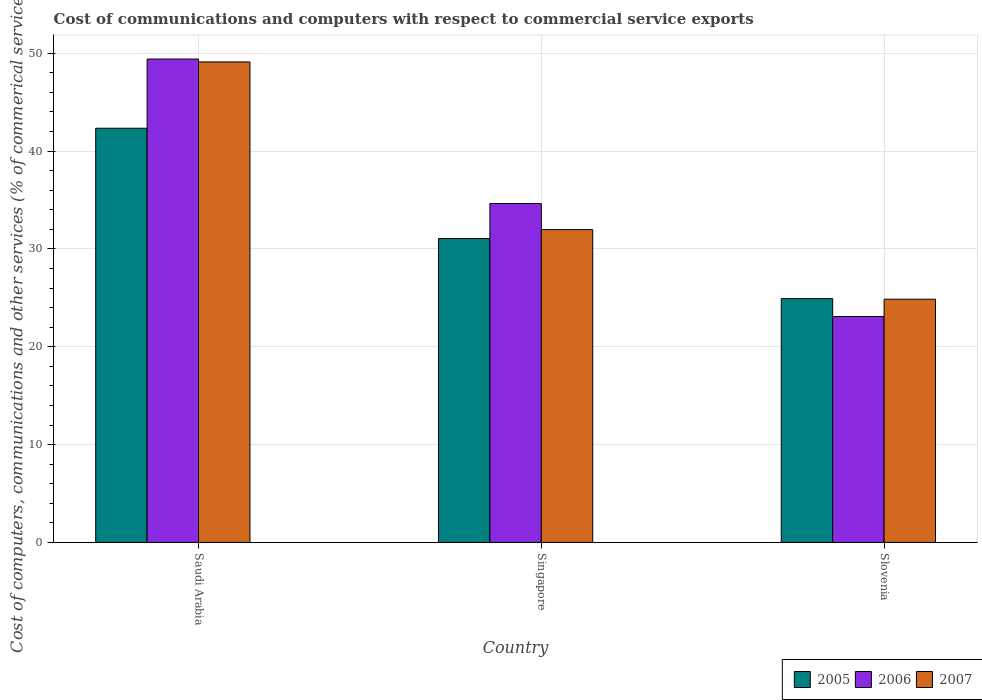Are the number of bars per tick equal to the number of legend labels?
Your answer should be very brief. Yes. Are the number of bars on each tick of the X-axis equal?
Your response must be concise. Yes. How many bars are there on the 3rd tick from the left?
Your answer should be very brief. 3. How many bars are there on the 1st tick from the right?
Your answer should be compact. 3. What is the label of the 1st group of bars from the left?
Ensure brevity in your answer.  Saudi Arabia. What is the cost of communications and computers in 2005 in Slovenia?
Your response must be concise. 24.93. Across all countries, what is the maximum cost of communications and computers in 2007?
Your answer should be very brief. 49.11. Across all countries, what is the minimum cost of communications and computers in 2005?
Keep it short and to the point. 24.93. In which country was the cost of communications and computers in 2007 maximum?
Your answer should be very brief. Saudi Arabia. In which country was the cost of communications and computers in 2007 minimum?
Offer a terse response. Slovenia. What is the total cost of communications and computers in 2006 in the graph?
Offer a terse response. 107.15. What is the difference between the cost of communications and computers in 2007 in Saudi Arabia and that in Slovenia?
Your response must be concise. 24.25. What is the difference between the cost of communications and computers in 2007 in Saudi Arabia and the cost of communications and computers in 2005 in Singapore?
Provide a short and direct response. 18.05. What is the average cost of communications and computers in 2007 per country?
Offer a terse response. 35.32. What is the difference between the cost of communications and computers of/in 2007 and cost of communications and computers of/in 2005 in Saudi Arabia?
Provide a short and direct response. 6.77. What is the ratio of the cost of communications and computers in 2007 in Saudi Arabia to that in Slovenia?
Ensure brevity in your answer.  1.98. Is the cost of communications and computers in 2005 in Singapore less than that in Slovenia?
Offer a very short reply. No. What is the difference between the highest and the second highest cost of communications and computers in 2005?
Your answer should be very brief. -17.41. What is the difference between the highest and the lowest cost of communications and computers in 2007?
Provide a short and direct response. 24.25. Is the sum of the cost of communications and computers in 2006 in Saudi Arabia and Slovenia greater than the maximum cost of communications and computers in 2005 across all countries?
Your response must be concise. Yes. How many countries are there in the graph?
Make the answer very short. 3. Does the graph contain any zero values?
Ensure brevity in your answer.  No. Where does the legend appear in the graph?
Your response must be concise. Bottom right. How many legend labels are there?
Give a very brief answer. 3. What is the title of the graph?
Your response must be concise. Cost of communications and computers with respect to commercial service exports. Does "2008" appear as one of the legend labels in the graph?
Provide a succinct answer. No. What is the label or title of the X-axis?
Offer a terse response. Country. What is the label or title of the Y-axis?
Give a very brief answer. Cost of computers, communications and other services (% of commerical service exports). What is the Cost of computers, communications and other services (% of commerical service exports) of 2005 in Saudi Arabia?
Your answer should be compact. 42.34. What is the Cost of computers, communications and other services (% of commerical service exports) in 2006 in Saudi Arabia?
Ensure brevity in your answer.  49.41. What is the Cost of computers, communications and other services (% of commerical service exports) in 2007 in Saudi Arabia?
Make the answer very short. 49.11. What is the Cost of computers, communications and other services (% of commerical service exports) of 2005 in Singapore?
Offer a very short reply. 31.07. What is the Cost of computers, communications and other services (% of commerical service exports) of 2006 in Singapore?
Your response must be concise. 34.64. What is the Cost of computers, communications and other services (% of commerical service exports) in 2007 in Singapore?
Your response must be concise. 31.98. What is the Cost of computers, communications and other services (% of commerical service exports) in 2005 in Slovenia?
Offer a very short reply. 24.93. What is the Cost of computers, communications and other services (% of commerical service exports) of 2006 in Slovenia?
Offer a very short reply. 23.09. What is the Cost of computers, communications and other services (% of commerical service exports) in 2007 in Slovenia?
Your answer should be very brief. 24.86. Across all countries, what is the maximum Cost of computers, communications and other services (% of commerical service exports) of 2005?
Give a very brief answer. 42.34. Across all countries, what is the maximum Cost of computers, communications and other services (% of commerical service exports) of 2006?
Give a very brief answer. 49.41. Across all countries, what is the maximum Cost of computers, communications and other services (% of commerical service exports) of 2007?
Your response must be concise. 49.11. Across all countries, what is the minimum Cost of computers, communications and other services (% of commerical service exports) in 2005?
Offer a very short reply. 24.93. Across all countries, what is the minimum Cost of computers, communications and other services (% of commerical service exports) of 2006?
Keep it short and to the point. 23.09. Across all countries, what is the minimum Cost of computers, communications and other services (% of commerical service exports) of 2007?
Your response must be concise. 24.86. What is the total Cost of computers, communications and other services (% of commerical service exports) of 2005 in the graph?
Make the answer very short. 98.33. What is the total Cost of computers, communications and other services (% of commerical service exports) in 2006 in the graph?
Keep it short and to the point. 107.15. What is the total Cost of computers, communications and other services (% of commerical service exports) of 2007 in the graph?
Give a very brief answer. 105.95. What is the difference between the Cost of computers, communications and other services (% of commerical service exports) of 2005 in Saudi Arabia and that in Singapore?
Your answer should be compact. 11.27. What is the difference between the Cost of computers, communications and other services (% of commerical service exports) in 2006 in Saudi Arabia and that in Singapore?
Keep it short and to the point. 14.77. What is the difference between the Cost of computers, communications and other services (% of commerical service exports) in 2007 in Saudi Arabia and that in Singapore?
Your response must be concise. 17.14. What is the difference between the Cost of computers, communications and other services (% of commerical service exports) of 2005 in Saudi Arabia and that in Slovenia?
Offer a terse response. 17.41. What is the difference between the Cost of computers, communications and other services (% of commerical service exports) in 2006 in Saudi Arabia and that in Slovenia?
Your answer should be very brief. 26.32. What is the difference between the Cost of computers, communications and other services (% of commerical service exports) of 2007 in Saudi Arabia and that in Slovenia?
Provide a succinct answer. 24.25. What is the difference between the Cost of computers, communications and other services (% of commerical service exports) of 2005 in Singapore and that in Slovenia?
Provide a short and direct response. 6.14. What is the difference between the Cost of computers, communications and other services (% of commerical service exports) in 2006 in Singapore and that in Slovenia?
Offer a very short reply. 11.55. What is the difference between the Cost of computers, communications and other services (% of commerical service exports) of 2007 in Singapore and that in Slovenia?
Give a very brief answer. 7.11. What is the difference between the Cost of computers, communications and other services (% of commerical service exports) in 2005 in Saudi Arabia and the Cost of computers, communications and other services (% of commerical service exports) in 2006 in Singapore?
Offer a terse response. 7.69. What is the difference between the Cost of computers, communications and other services (% of commerical service exports) in 2005 in Saudi Arabia and the Cost of computers, communications and other services (% of commerical service exports) in 2007 in Singapore?
Provide a succinct answer. 10.36. What is the difference between the Cost of computers, communications and other services (% of commerical service exports) of 2006 in Saudi Arabia and the Cost of computers, communications and other services (% of commerical service exports) of 2007 in Singapore?
Ensure brevity in your answer.  17.44. What is the difference between the Cost of computers, communications and other services (% of commerical service exports) of 2005 in Saudi Arabia and the Cost of computers, communications and other services (% of commerical service exports) of 2006 in Slovenia?
Your answer should be compact. 19.25. What is the difference between the Cost of computers, communications and other services (% of commerical service exports) in 2005 in Saudi Arabia and the Cost of computers, communications and other services (% of commerical service exports) in 2007 in Slovenia?
Your answer should be compact. 17.48. What is the difference between the Cost of computers, communications and other services (% of commerical service exports) of 2006 in Saudi Arabia and the Cost of computers, communications and other services (% of commerical service exports) of 2007 in Slovenia?
Ensure brevity in your answer.  24.55. What is the difference between the Cost of computers, communications and other services (% of commerical service exports) of 2005 in Singapore and the Cost of computers, communications and other services (% of commerical service exports) of 2006 in Slovenia?
Keep it short and to the point. 7.97. What is the difference between the Cost of computers, communications and other services (% of commerical service exports) of 2005 in Singapore and the Cost of computers, communications and other services (% of commerical service exports) of 2007 in Slovenia?
Your response must be concise. 6.2. What is the difference between the Cost of computers, communications and other services (% of commerical service exports) in 2006 in Singapore and the Cost of computers, communications and other services (% of commerical service exports) in 2007 in Slovenia?
Make the answer very short. 9.78. What is the average Cost of computers, communications and other services (% of commerical service exports) of 2005 per country?
Make the answer very short. 32.78. What is the average Cost of computers, communications and other services (% of commerical service exports) of 2006 per country?
Provide a succinct answer. 35.72. What is the average Cost of computers, communications and other services (% of commerical service exports) in 2007 per country?
Give a very brief answer. 35.32. What is the difference between the Cost of computers, communications and other services (% of commerical service exports) in 2005 and Cost of computers, communications and other services (% of commerical service exports) in 2006 in Saudi Arabia?
Ensure brevity in your answer.  -7.07. What is the difference between the Cost of computers, communications and other services (% of commerical service exports) of 2005 and Cost of computers, communications and other services (% of commerical service exports) of 2007 in Saudi Arabia?
Make the answer very short. -6.77. What is the difference between the Cost of computers, communications and other services (% of commerical service exports) of 2006 and Cost of computers, communications and other services (% of commerical service exports) of 2007 in Saudi Arabia?
Provide a succinct answer. 0.3. What is the difference between the Cost of computers, communications and other services (% of commerical service exports) in 2005 and Cost of computers, communications and other services (% of commerical service exports) in 2006 in Singapore?
Offer a very short reply. -3.58. What is the difference between the Cost of computers, communications and other services (% of commerical service exports) in 2005 and Cost of computers, communications and other services (% of commerical service exports) in 2007 in Singapore?
Your answer should be very brief. -0.91. What is the difference between the Cost of computers, communications and other services (% of commerical service exports) of 2006 and Cost of computers, communications and other services (% of commerical service exports) of 2007 in Singapore?
Make the answer very short. 2.67. What is the difference between the Cost of computers, communications and other services (% of commerical service exports) of 2005 and Cost of computers, communications and other services (% of commerical service exports) of 2006 in Slovenia?
Provide a succinct answer. 1.83. What is the difference between the Cost of computers, communications and other services (% of commerical service exports) in 2005 and Cost of computers, communications and other services (% of commerical service exports) in 2007 in Slovenia?
Provide a succinct answer. 0.06. What is the difference between the Cost of computers, communications and other services (% of commerical service exports) in 2006 and Cost of computers, communications and other services (% of commerical service exports) in 2007 in Slovenia?
Your answer should be compact. -1.77. What is the ratio of the Cost of computers, communications and other services (% of commerical service exports) in 2005 in Saudi Arabia to that in Singapore?
Ensure brevity in your answer.  1.36. What is the ratio of the Cost of computers, communications and other services (% of commerical service exports) in 2006 in Saudi Arabia to that in Singapore?
Your response must be concise. 1.43. What is the ratio of the Cost of computers, communications and other services (% of commerical service exports) of 2007 in Saudi Arabia to that in Singapore?
Provide a succinct answer. 1.54. What is the ratio of the Cost of computers, communications and other services (% of commerical service exports) in 2005 in Saudi Arabia to that in Slovenia?
Your response must be concise. 1.7. What is the ratio of the Cost of computers, communications and other services (% of commerical service exports) in 2006 in Saudi Arabia to that in Slovenia?
Ensure brevity in your answer.  2.14. What is the ratio of the Cost of computers, communications and other services (% of commerical service exports) of 2007 in Saudi Arabia to that in Slovenia?
Provide a short and direct response. 1.98. What is the ratio of the Cost of computers, communications and other services (% of commerical service exports) in 2005 in Singapore to that in Slovenia?
Provide a short and direct response. 1.25. What is the ratio of the Cost of computers, communications and other services (% of commerical service exports) in 2006 in Singapore to that in Slovenia?
Offer a very short reply. 1.5. What is the ratio of the Cost of computers, communications and other services (% of commerical service exports) in 2007 in Singapore to that in Slovenia?
Ensure brevity in your answer.  1.29. What is the difference between the highest and the second highest Cost of computers, communications and other services (% of commerical service exports) of 2005?
Give a very brief answer. 11.27. What is the difference between the highest and the second highest Cost of computers, communications and other services (% of commerical service exports) of 2006?
Ensure brevity in your answer.  14.77. What is the difference between the highest and the second highest Cost of computers, communications and other services (% of commerical service exports) of 2007?
Offer a terse response. 17.14. What is the difference between the highest and the lowest Cost of computers, communications and other services (% of commerical service exports) of 2005?
Your answer should be compact. 17.41. What is the difference between the highest and the lowest Cost of computers, communications and other services (% of commerical service exports) in 2006?
Offer a very short reply. 26.32. What is the difference between the highest and the lowest Cost of computers, communications and other services (% of commerical service exports) in 2007?
Your answer should be compact. 24.25. 